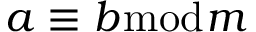Convert formula to latex. <formula><loc_0><loc_0><loc_500><loc_500>a \equiv b { \bmod { m } }</formula> 